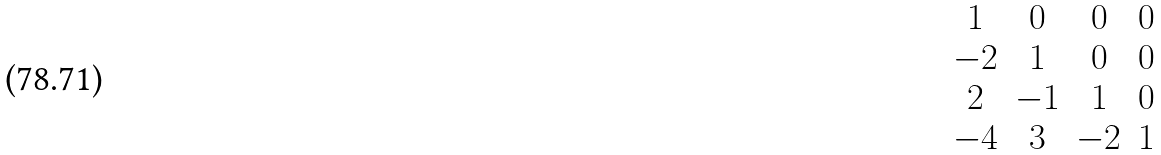Convert formula to latex. <formula><loc_0><loc_0><loc_500><loc_500>\begin{matrix} 1 & 0 & 0 & 0 \\ - 2 & 1 & 0 & 0 \\ 2 & - 1 & 1 & 0 \\ - 4 & 3 & - 2 & 1 \end{matrix}</formula> 